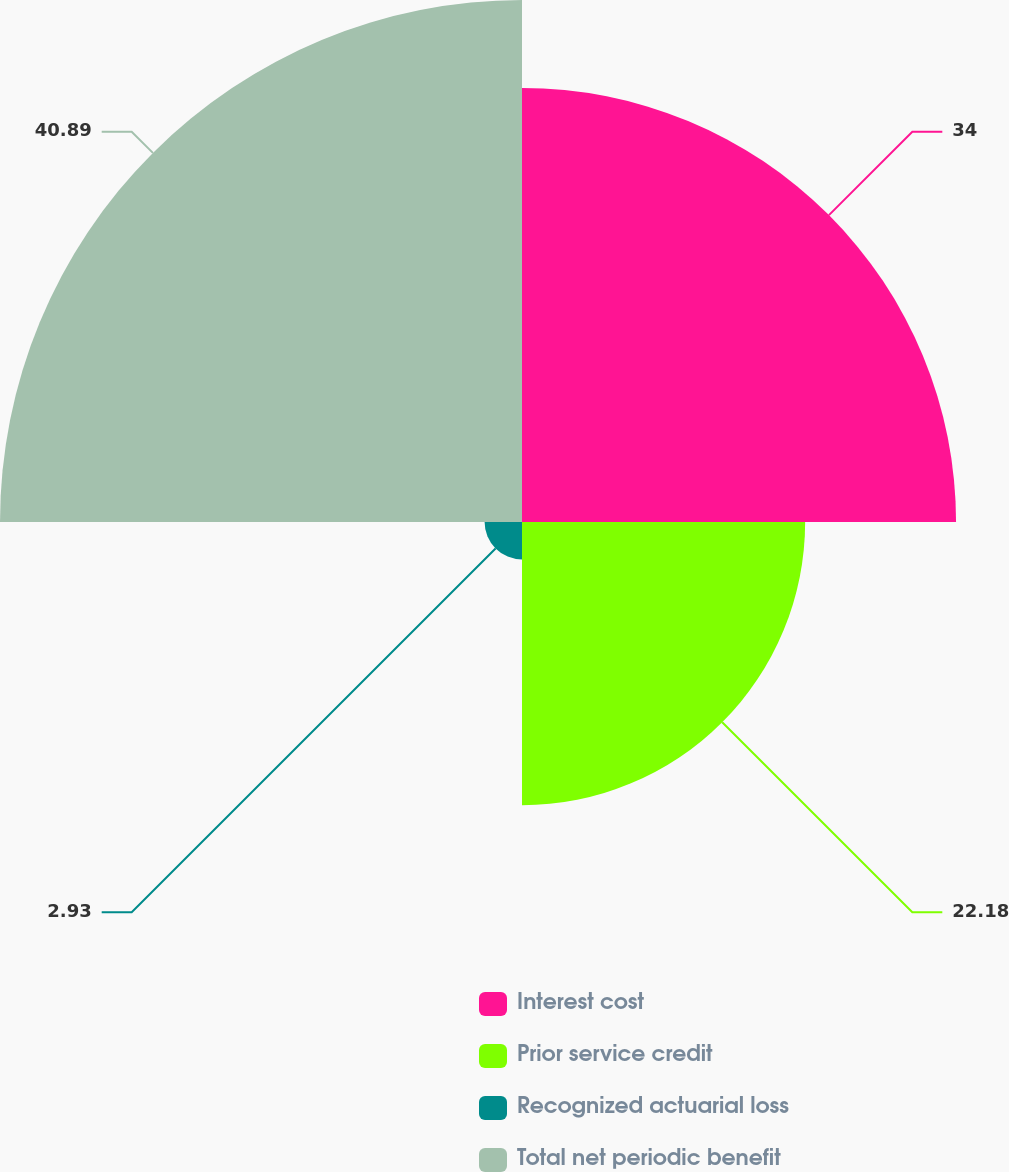Convert chart. <chart><loc_0><loc_0><loc_500><loc_500><pie_chart><fcel>Interest cost<fcel>Prior service credit<fcel>Recognized actuarial loss<fcel>Total net periodic benefit<nl><fcel>34.0%<fcel>22.18%<fcel>2.93%<fcel>40.89%<nl></chart> 